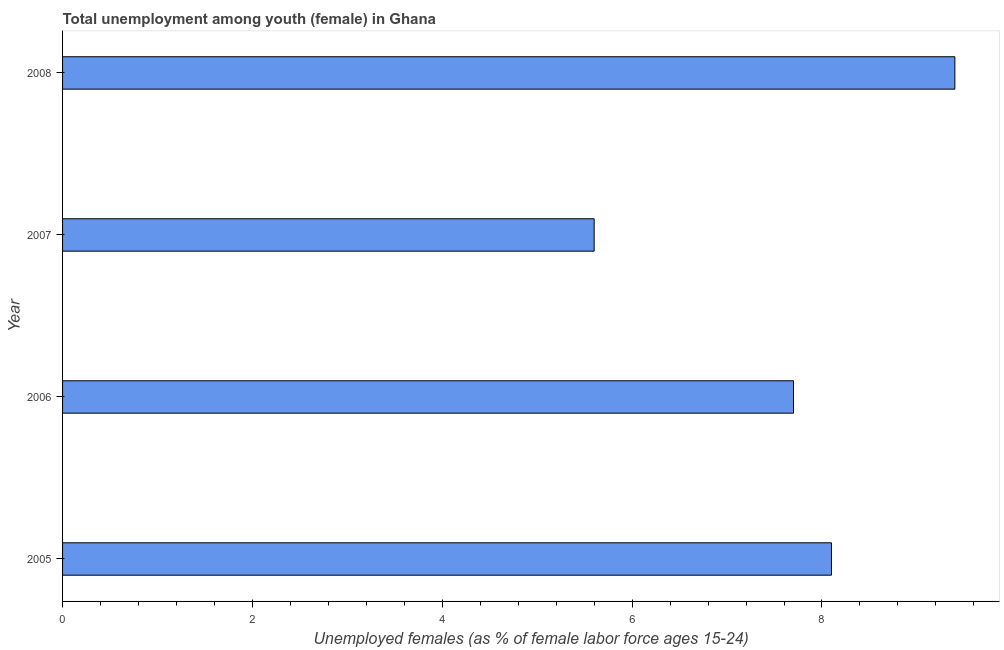Does the graph contain any zero values?
Give a very brief answer. No. What is the title of the graph?
Keep it short and to the point. Total unemployment among youth (female) in Ghana. What is the label or title of the X-axis?
Give a very brief answer. Unemployed females (as % of female labor force ages 15-24). What is the label or title of the Y-axis?
Provide a succinct answer. Year. What is the unemployed female youth population in 2008?
Your response must be concise. 9.4. Across all years, what is the maximum unemployed female youth population?
Make the answer very short. 9.4. Across all years, what is the minimum unemployed female youth population?
Provide a succinct answer. 5.6. What is the sum of the unemployed female youth population?
Offer a very short reply. 30.8. What is the median unemployed female youth population?
Make the answer very short. 7.9. In how many years, is the unemployed female youth population greater than 6 %?
Keep it short and to the point. 3. What is the ratio of the unemployed female youth population in 2005 to that in 2007?
Your answer should be very brief. 1.45. Is the difference between the unemployed female youth population in 2006 and 2007 greater than the difference between any two years?
Your answer should be very brief. No. Is the sum of the unemployed female youth population in 2006 and 2008 greater than the maximum unemployed female youth population across all years?
Make the answer very short. Yes. Are all the bars in the graph horizontal?
Offer a terse response. Yes. How many years are there in the graph?
Your answer should be compact. 4. What is the Unemployed females (as % of female labor force ages 15-24) in 2005?
Your answer should be very brief. 8.1. What is the Unemployed females (as % of female labor force ages 15-24) in 2006?
Give a very brief answer. 7.7. What is the Unemployed females (as % of female labor force ages 15-24) in 2007?
Your response must be concise. 5.6. What is the Unemployed females (as % of female labor force ages 15-24) in 2008?
Your response must be concise. 9.4. What is the difference between the Unemployed females (as % of female labor force ages 15-24) in 2005 and 2007?
Make the answer very short. 2.5. What is the difference between the Unemployed females (as % of female labor force ages 15-24) in 2006 and 2007?
Your response must be concise. 2.1. What is the difference between the Unemployed females (as % of female labor force ages 15-24) in 2006 and 2008?
Make the answer very short. -1.7. What is the ratio of the Unemployed females (as % of female labor force ages 15-24) in 2005 to that in 2006?
Your answer should be very brief. 1.05. What is the ratio of the Unemployed females (as % of female labor force ages 15-24) in 2005 to that in 2007?
Your response must be concise. 1.45. What is the ratio of the Unemployed females (as % of female labor force ages 15-24) in 2005 to that in 2008?
Provide a succinct answer. 0.86. What is the ratio of the Unemployed females (as % of female labor force ages 15-24) in 2006 to that in 2007?
Make the answer very short. 1.38. What is the ratio of the Unemployed females (as % of female labor force ages 15-24) in 2006 to that in 2008?
Offer a very short reply. 0.82. What is the ratio of the Unemployed females (as % of female labor force ages 15-24) in 2007 to that in 2008?
Provide a succinct answer. 0.6. 